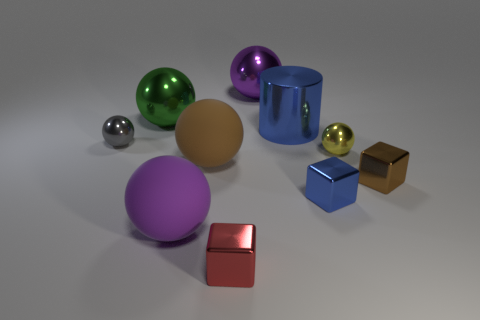Do the thing that is to the right of the yellow ball and the big purple thing behind the large green object have the same material?
Give a very brief answer. Yes. There is a purple thing that is behind the cylinder; what is its size?
Your answer should be compact. Large. What material is the other tiny object that is the same shape as the small yellow metallic object?
Your answer should be very brief. Metal. Is there anything else that is the same size as the yellow shiny thing?
Keep it short and to the point. Yes. The large shiny object that is left of the purple shiny ball has what shape?
Provide a succinct answer. Sphere. What number of rubber objects are the same shape as the brown metal object?
Provide a succinct answer. 0. Are there an equal number of yellow things in front of the yellow object and red shiny blocks to the left of the small red cube?
Ensure brevity in your answer.  Yes. Are there any large purple blocks made of the same material as the blue cube?
Provide a short and direct response. No. Are the yellow sphere and the blue cylinder made of the same material?
Offer a terse response. Yes. What number of purple things are either big things or small balls?
Keep it short and to the point. 2. 